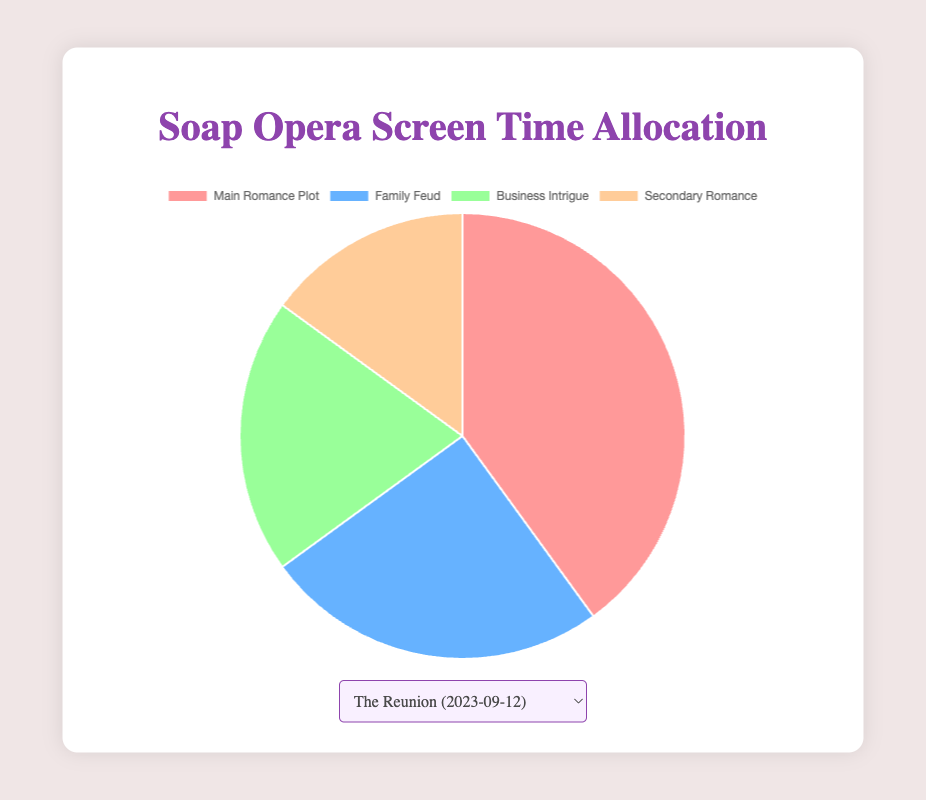Which storyline receives the most screen time in "The Reunion" episode? The episode's title and screen time allocation are specified in the figure. The "Main Romance Plot" occupies 40% of the total screen time, which is the highest compared to other storylines.
Answer: Main Romance Plot In the "Secrets Unveiled" episode, which plot has the least screen time? The episode's details show four storylines' screen time percentages. The "Secondary Romance" plot has the smallest percentage at 10%.
Answer: Secondary Romance How does the screen time of "Family Feud" compare between "The Reunion" and "Secrets Unveiled"? The figure provides screen time data for both episodes. "The Reunion" allocates 25% to "Family Feud," while "Secrets Unveiled" allocates 30%, showing an increase in screen time from one episode to the next.
Answer: Increase Calculate the total percentage of screen time devoted to romance plots (main and secondary) in "Betrayal" episode. The figure lists the screen times for both romance plots in "Betrayal": "Main Romance Plot" at 45% and "Secondary Romance" at 20%. Adding them gives 45% + 20% = 65%.
Answer: 65% What is the difference in screen time for "Business Intrigue" between "Betrayal" and "A New Beginning"? In "Betrayal," "Business Intrigue" occupies 15% of the screen time, while in "A New Beginning" it also occupies 15%. The difference in screen time is 15% - 15% = 0%.
Answer: 0% In "A New Beginning," is the screen time for "Secondary Romance" greater than "Business Intrigue"? The visual attributes in the figure indicate "Secondary Romance" takes up 20% while "Business Intrigue" is allocated 15%. Therefore, "Secondary Romance" has more screen time.
Answer: Yes Which episode dedicates the most screen time to "Main Romance Plot"? Reviewing screen time allocations across all episodes, "Betrayal" devotes the largest percentage to "Main Romance Plot" at 45%.
Answer: Betrayal Compare the total screen time for "Family Feud" across all episodes. Which episode has the highest allocation? The figure lists the percentages allocated to "Family Feud" for each episode: 25% in "The Reunion," 30% in "Secrets Unveiled," 20% in "Betrayal," and 25% in "A New Beginning." The highest allocation is in "Secrets Unveiled" at 30%.
Answer: Secrets Unveiled What is the average screen time across all episodes for the "Business Intrigue" plot? Adding the percentages for "Business Intrigue" (20% + 25% + 15% + 15%) sums to 75%. Dividing by the number of episodes (4) gives 75% / 4 = 18.75%.
Answer: 18.75% Which plot has a consistent screen time percentage in any two consecutive episodes? Reviewing the plots across episodes, "Business Intrigue" consistently holds 15% of the screen time in the episodes "Betrayal" and "A New Beginning."
Answer: Business Intrigue 